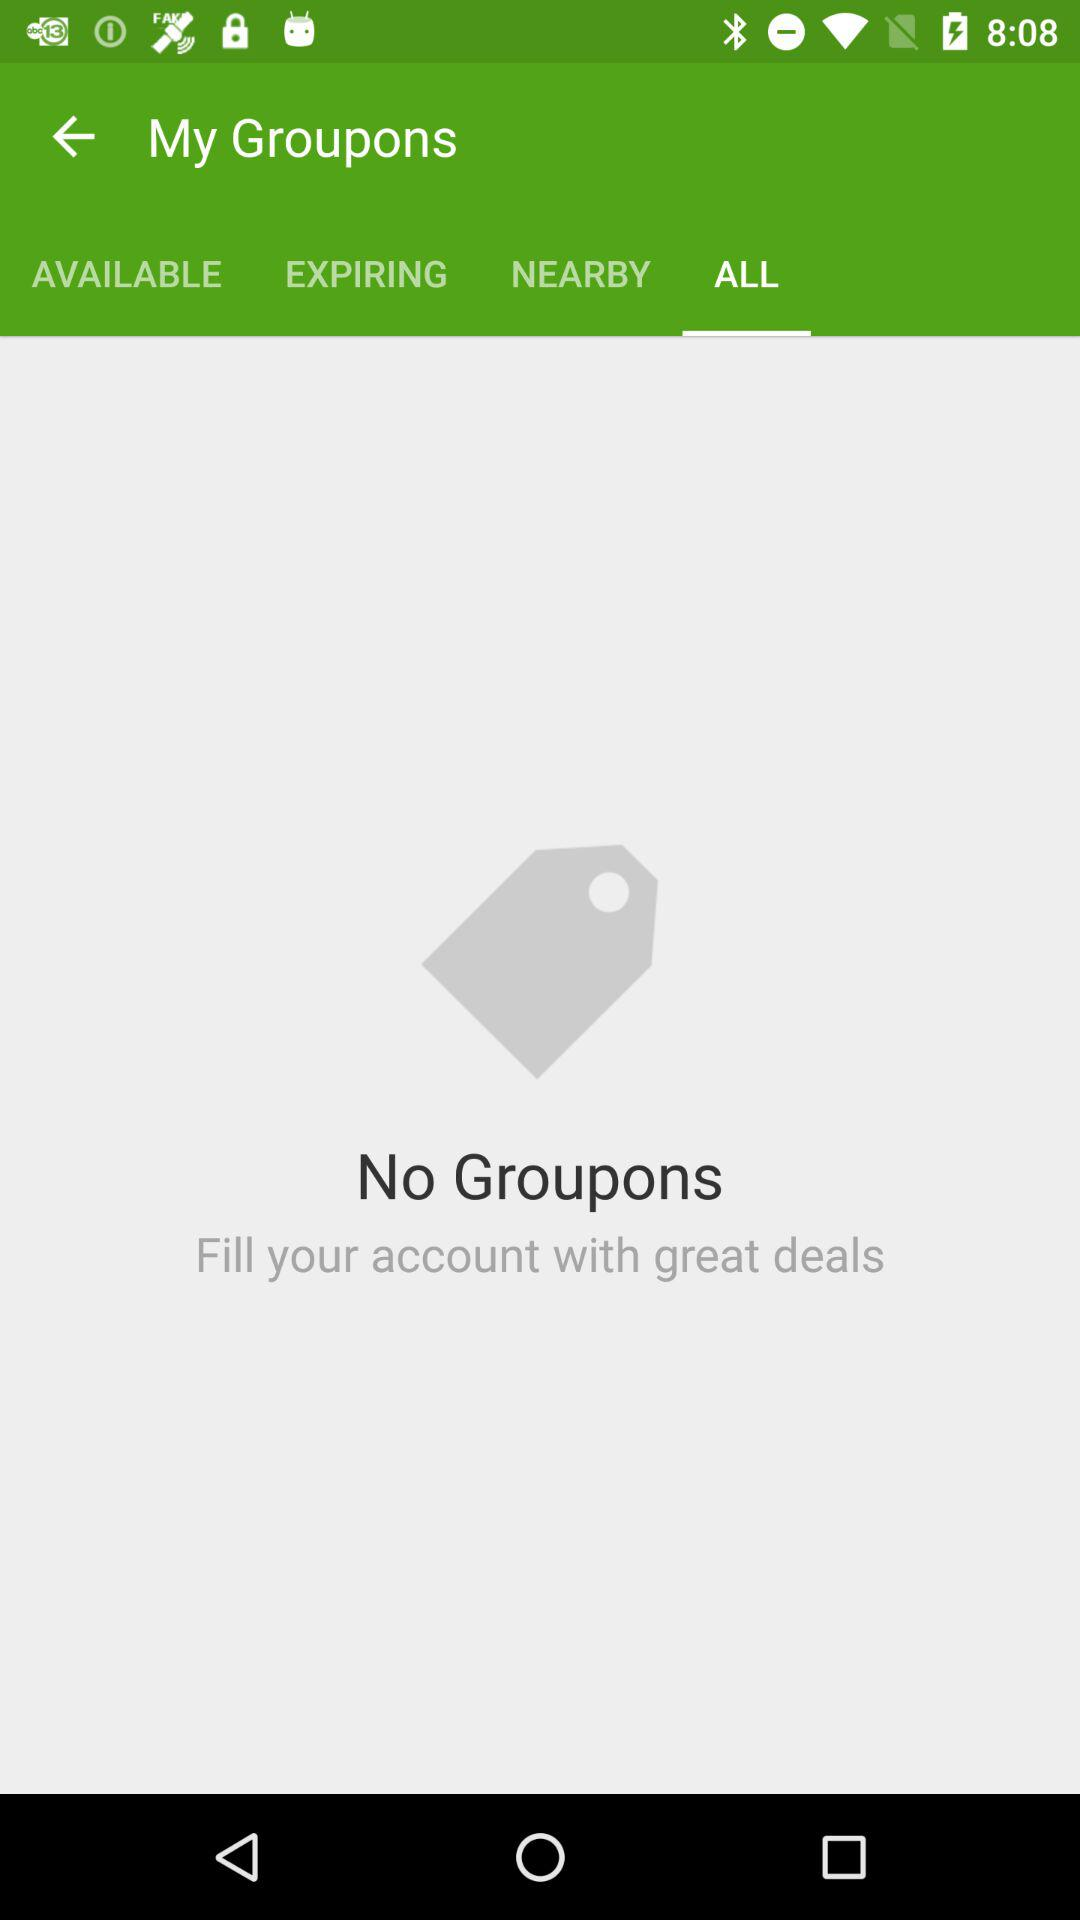How many Groupons do I have?
Answer the question using a single word or phrase. 0 